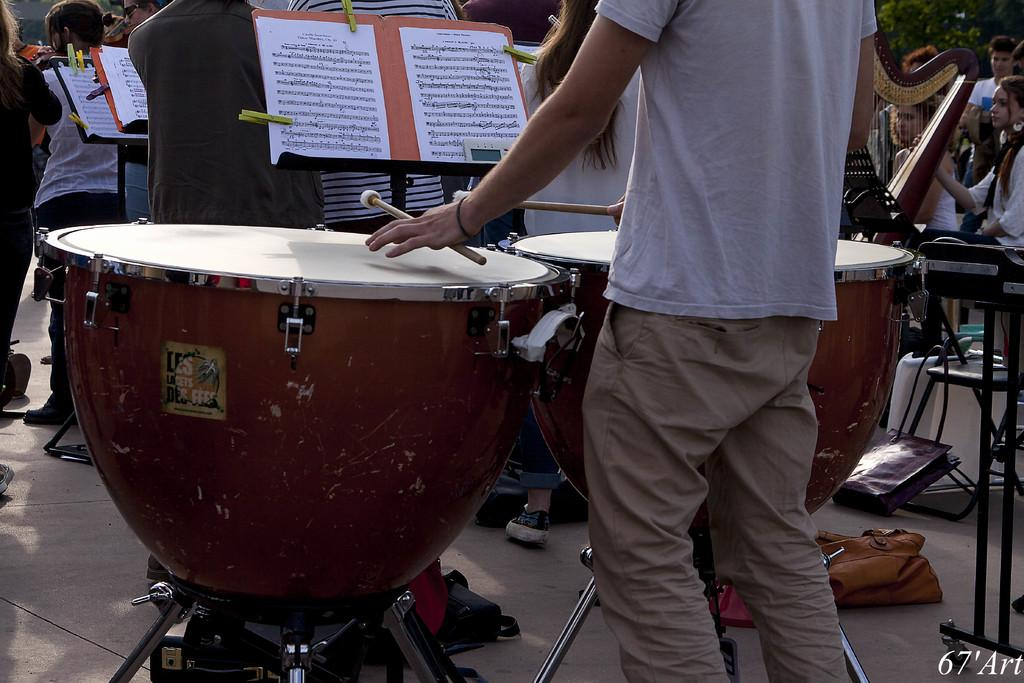Who or what can be seen in the image? There are people in the image. What are the people doing in the image? The people are playing musical instruments in the image. What else can be seen on the papers in the image? There is written text on the papers in the image. What are the clips used for in the image? The clips are used to hold the papers in the image. What type of natural environment is visible in the image? There are trees in the image, indicating a natural environment. What is the surface that the people and instruments are placed on in the image? The floor is visible in the image. Can you see a cave in the background of the image? There is no cave present in the image. What type of star is shining brightly in the sky in the image? There is no star visible in the image, as it is focused on the people, musical instruments, and other items on the floor. 